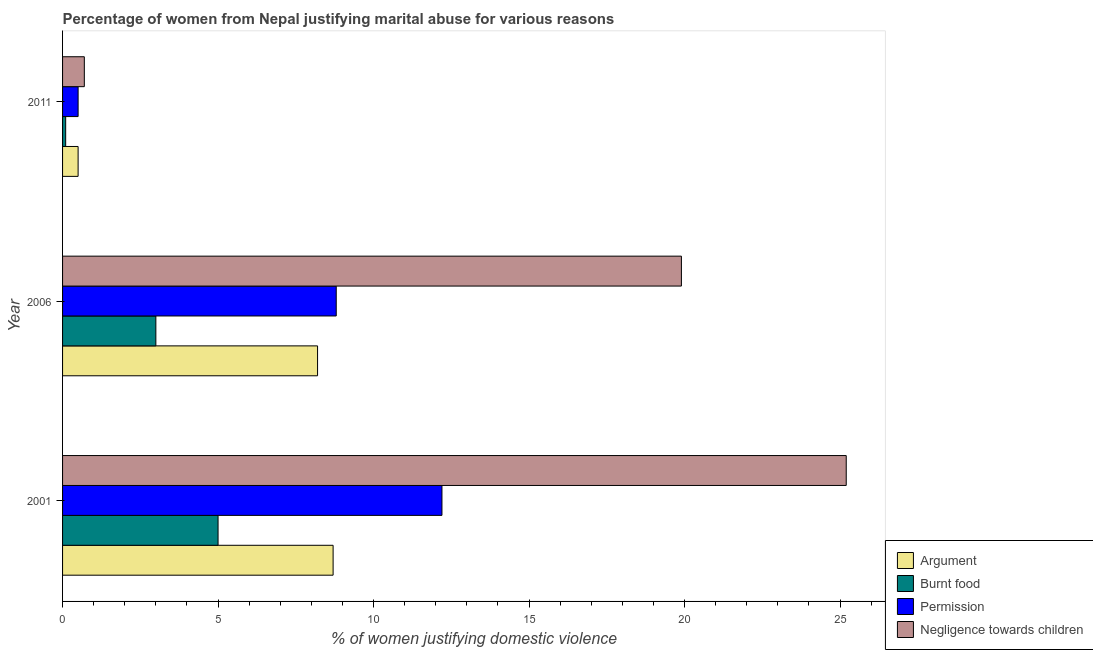How many groups of bars are there?
Provide a succinct answer. 3. Are the number of bars on each tick of the Y-axis equal?
Provide a succinct answer. Yes. What is the label of the 1st group of bars from the top?
Provide a succinct answer. 2011. In how many cases, is the number of bars for a given year not equal to the number of legend labels?
Keep it short and to the point. 0. What is the percentage of women justifying abuse for going without permission in 2011?
Your answer should be compact. 0.5. Across all years, what is the maximum percentage of women justifying abuse for burning food?
Your response must be concise. 5. In which year was the percentage of women justifying abuse for burning food minimum?
Give a very brief answer. 2011. What is the total percentage of women justifying abuse for burning food in the graph?
Make the answer very short. 8.1. What is the average percentage of women justifying abuse for showing negligence towards children per year?
Make the answer very short. 15.27. In how many years, is the percentage of women justifying abuse for showing negligence towards children greater than 4 %?
Provide a succinct answer. 2. Is the difference between the percentage of women justifying abuse for showing negligence towards children in 2001 and 2006 greater than the difference between the percentage of women justifying abuse for burning food in 2001 and 2006?
Your answer should be compact. Yes. What is the difference between the highest and the second highest percentage of women justifying abuse for showing negligence towards children?
Keep it short and to the point. 5.3. What is the difference between the highest and the lowest percentage of women justifying abuse for burning food?
Provide a succinct answer. 4.9. What does the 3rd bar from the top in 2006 represents?
Give a very brief answer. Burnt food. What does the 4th bar from the bottom in 2006 represents?
Your response must be concise. Negligence towards children. How many bars are there?
Offer a very short reply. 12. How many years are there in the graph?
Your answer should be compact. 3. What is the difference between two consecutive major ticks on the X-axis?
Your answer should be very brief. 5. Does the graph contain any zero values?
Offer a very short reply. No. Does the graph contain grids?
Offer a terse response. No. Where does the legend appear in the graph?
Provide a short and direct response. Bottom right. How many legend labels are there?
Provide a succinct answer. 4. What is the title of the graph?
Keep it short and to the point. Percentage of women from Nepal justifying marital abuse for various reasons. What is the label or title of the X-axis?
Your response must be concise. % of women justifying domestic violence. What is the % of women justifying domestic violence of Argument in 2001?
Provide a short and direct response. 8.7. What is the % of women justifying domestic violence in Permission in 2001?
Offer a very short reply. 12.2. What is the % of women justifying domestic violence in Negligence towards children in 2001?
Offer a terse response. 25.2. What is the % of women justifying domestic violence in Argument in 2006?
Your answer should be very brief. 8.2. What is the % of women justifying domestic violence in Burnt food in 2006?
Give a very brief answer. 3. What is the % of women justifying domestic violence in Negligence towards children in 2006?
Ensure brevity in your answer.  19.9. What is the % of women justifying domestic violence in Argument in 2011?
Offer a very short reply. 0.5. What is the % of women justifying domestic violence of Permission in 2011?
Your answer should be very brief. 0.5. Across all years, what is the maximum % of women justifying domestic violence of Argument?
Your answer should be very brief. 8.7. Across all years, what is the maximum % of women justifying domestic violence of Burnt food?
Provide a short and direct response. 5. Across all years, what is the maximum % of women justifying domestic violence in Negligence towards children?
Your answer should be compact. 25.2. What is the total % of women justifying domestic violence in Burnt food in the graph?
Make the answer very short. 8.1. What is the total % of women justifying domestic violence of Permission in the graph?
Your answer should be compact. 21.5. What is the total % of women justifying domestic violence of Negligence towards children in the graph?
Provide a short and direct response. 45.8. What is the difference between the % of women justifying domestic violence in Burnt food in 2001 and that in 2006?
Provide a short and direct response. 2. What is the difference between the % of women justifying domestic violence in Argument in 2001 and that in 2011?
Keep it short and to the point. 8.2. What is the difference between the % of women justifying domestic violence in Permission in 2001 and that in 2011?
Your answer should be very brief. 11.7. What is the difference between the % of women justifying domestic violence in Negligence towards children in 2001 and that in 2011?
Offer a terse response. 24.5. What is the difference between the % of women justifying domestic violence in Negligence towards children in 2006 and that in 2011?
Your response must be concise. 19.2. What is the difference between the % of women justifying domestic violence in Argument in 2001 and the % of women justifying domestic violence in Burnt food in 2006?
Provide a succinct answer. 5.7. What is the difference between the % of women justifying domestic violence of Argument in 2001 and the % of women justifying domestic violence of Permission in 2006?
Your answer should be very brief. -0.1. What is the difference between the % of women justifying domestic violence in Argument in 2001 and the % of women justifying domestic violence in Negligence towards children in 2006?
Ensure brevity in your answer.  -11.2. What is the difference between the % of women justifying domestic violence of Burnt food in 2001 and the % of women justifying domestic violence of Negligence towards children in 2006?
Give a very brief answer. -14.9. What is the difference between the % of women justifying domestic violence in Argument in 2001 and the % of women justifying domestic violence in Burnt food in 2011?
Provide a short and direct response. 8.6. What is the difference between the % of women justifying domestic violence of Burnt food in 2001 and the % of women justifying domestic violence of Permission in 2011?
Ensure brevity in your answer.  4.5. What is the difference between the % of women justifying domestic violence in Burnt food in 2001 and the % of women justifying domestic violence in Negligence towards children in 2011?
Your answer should be compact. 4.3. What is the difference between the % of women justifying domestic violence in Burnt food in 2006 and the % of women justifying domestic violence in Permission in 2011?
Keep it short and to the point. 2.5. What is the difference between the % of women justifying domestic violence in Burnt food in 2006 and the % of women justifying domestic violence in Negligence towards children in 2011?
Make the answer very short. 2.3. What is the average % of women justifying domestic violence in Argument per year?
Your answer should be very brief. 5.8. What is the average % of women justifying domestic violence in Burnt food per year?
Offer a terse response. 2.7. What is the average % of women justifying domestic violence of Permission per year?
Make the answer very short. 7.17. What is the average % of women justifying domestic violence in Negligence towards children per year?
Keep it short and to the point. 15.27. In the year 2001, what is the difference between the % of women justifying domestic violence in Argument and % of women justifying domestic violence in Permission?
Offer a terse response. -3.5. In the year 2001, what is the difference between the % of women justifying domestic violence in Argument and % of women justifying domestic violence in Negligence towards children?
Your response must be concise. -16.5. In the year 2001, what is the difference between the % of women justifying domestic violence of Burnt food and % of women justifying domestic violence of Negligence towards children?
Ensure brevity in your answer.  -20.2. In the year 2006, what is the difference between the % of women justifying domestic violence of Burnt food and % of women justifying domestic violence of Negligence towards children?
Offer a very short reply. -16.9. In the year 2011, what is the difference between the % of women justifying domestic violence of Argument and % of women justifying domestic violence of Burnt food?
Provide a succinct answer. 0.4. In the year 2011, what is the difference between the % of women justifying domestic violence in Argument and % of women justifying domestic violence in Negligence towards children?
Your answer should be compact. -0.2. In the year 2011, what is the difference between the % of women justifying domestic violence of Burnt food and % of women justifying domestic violence of Permission?
Your response must be concise. -0.4. What is the ratio of the % of women justifying domestic violence of Argument in 2001 to that in 2006?
Offer a very short reply. 1.06. What is the ratio of the % of women justifying domestic violence in Burnt food in 2001 to that in 2006?
Give a very brief answer. 1.67. What is the ratio of the % of women justifying domestic violence in Permission in 2001 to that in 2006?
Your response must be concise. 1.39. What is the ratio of the % of women justifying domestic violence in Negligence towards children in 2001 to that in 2006?
Your answer should be very brief. 1.27. What is the ratio of the % of women justifying domestic violence in Permission in 2001 to that in 2011?
Provide a short and direct response. 24.4. What is the ratio of the % of women justifying domestic violence of Argument in 2006 to that in 2011?
Your answer should be very brief. 16.4. What is the ratio of the % of women justifying domestic violence of Burnt food in 2006 to that in 2011?
Make the answer very short. 30. What is the ratio of the % of women justifying domestic violence in Negligence towards children in 2006 to that in 2011?
Keep it short and to the point. 28.43. What is the difference between the highest and the second highest % of women justifying domestic violence of Burnt food?
Provide a succinct answer. 2. What is the difference between the highest and the lowest % of women justifying domestic violence in Burnt food?
Your answer should be compact. 4.9. What is the difference between the highest and the lowest % of women justifying domestic violence of Permission?
Provide a short and direct response. 11.7. 